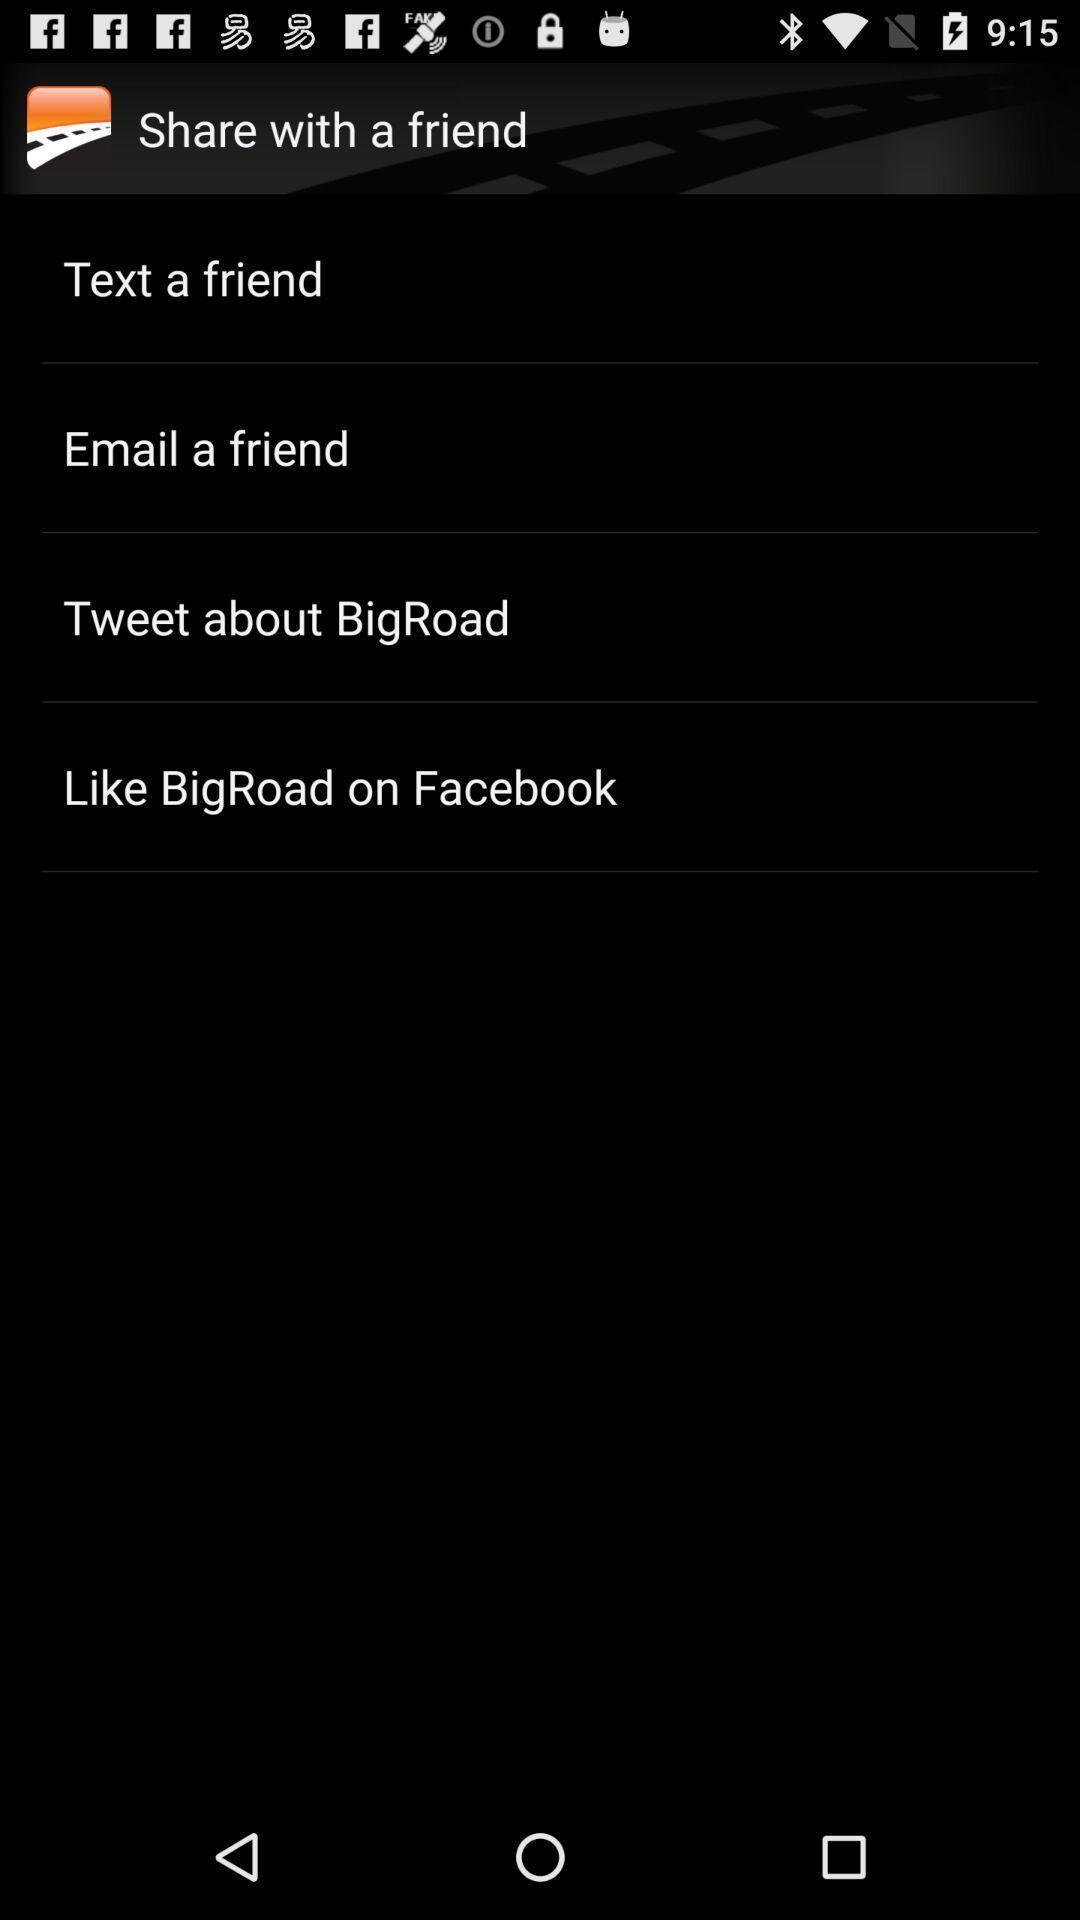Give me a narrative description of this picture. Page showing the multiple options. 